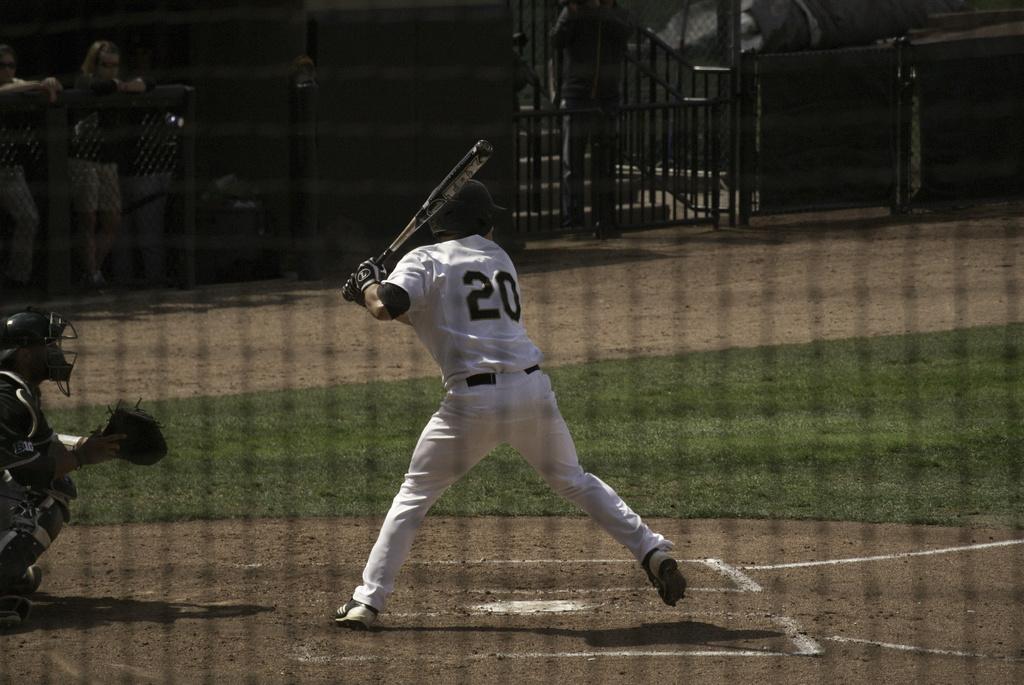What number player is up to bat?
Keep it short and to the point. 20. Is player number 20 at bat?
Ensure brevity in your answer.  Yes. 